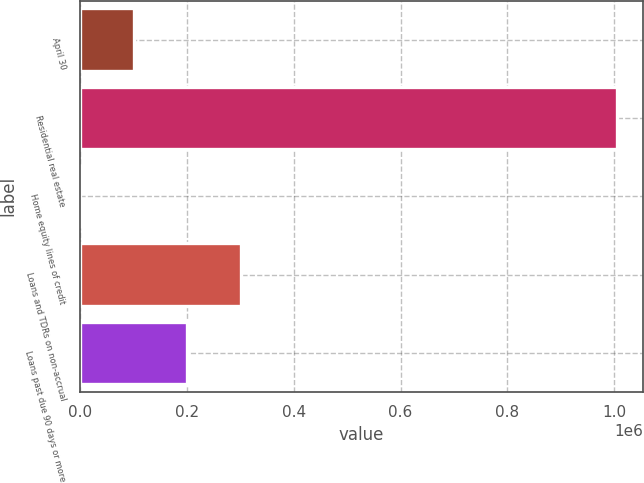<chart> <loc_0><loc_0><loc_500><loc_500><bar_chart><fcel>April 30<fcel>Residential real estate<fcel>Home equity lines of credit<fcel>Loans and TDRs on non-accrual<fcel>Loans past due 90 days or more<nl><fcel>100750<fcel>1.00428e+06<fcel>357<fcel>301535<fcel>201142<nl></chart> 